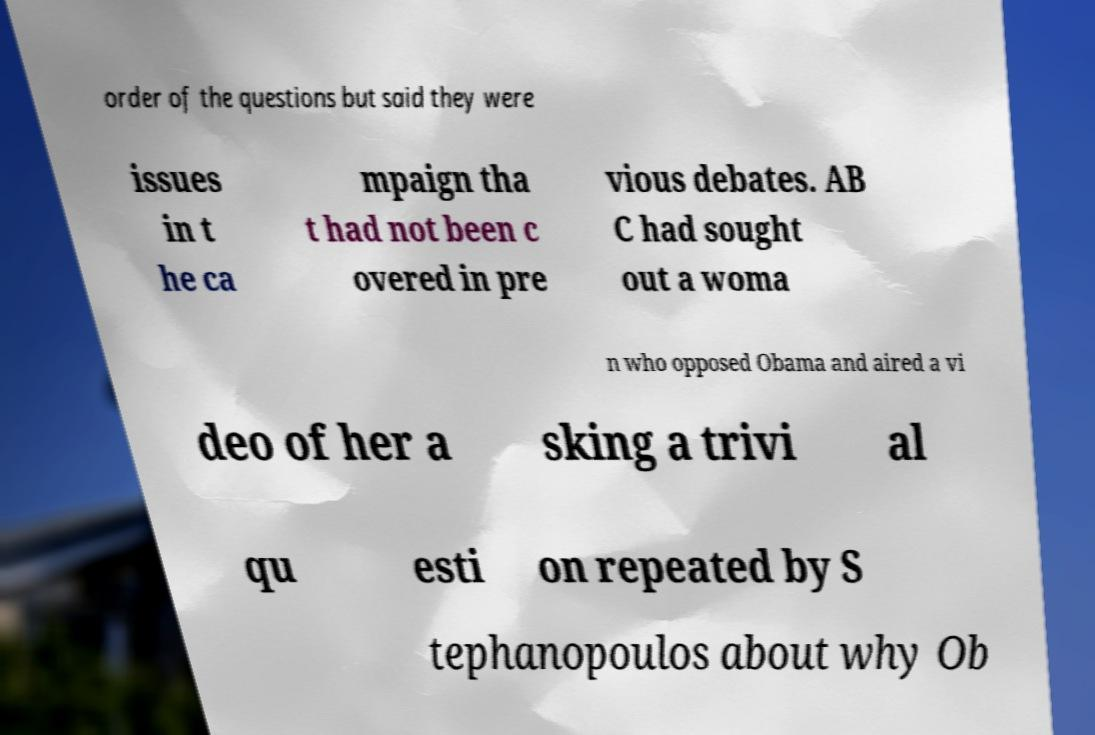Could you assist in decoding the text presented in this image and type it out clearly? order of the questions but said they were issues in t he ca mpaign tha t had not been c overed in pre vious debates. AB C had sought out a woma n who opposed Obama and aired a vi deo of her a sking a trivi al qu esti on repeated by S tephanopoulos about why Ob 